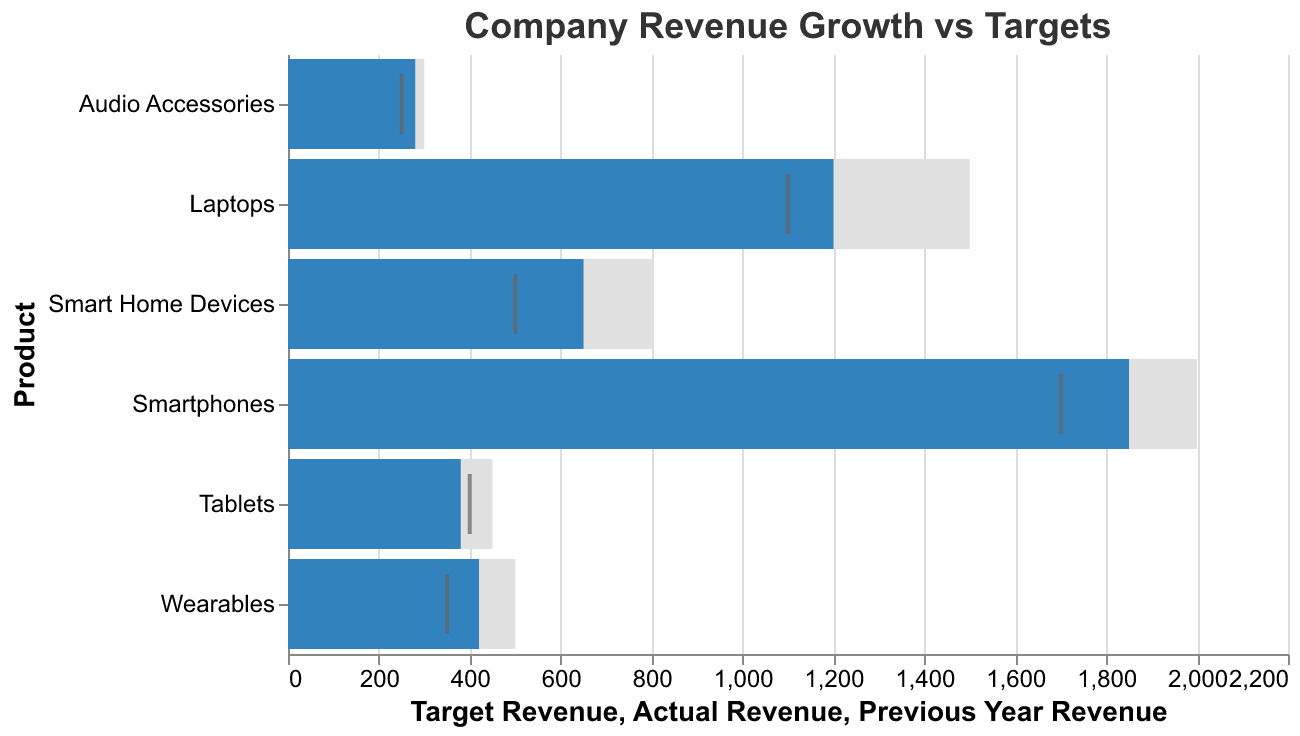How many product lines are displayed in the figure? Count each product listed on the y-axis, which includes Smartphones, Laptops, Smart Home Devices, Wearables, Tablets, and Audio Accessories, totaling six product lines.
Answer: Six What is the target revenue for Smart Home Devices? The target revenue for each product is visually represented by the length of the grey bar. For Smart Home Devices, it reaches up to 800 on the x-axis.
Answer: 800 Which product line achieved the highest actual revenue? Compare the lengths of the blue bars for each product. The Smartphones product line has the longest blue bar, indicating the highest actual revenue.
Answer: Smartphones Did the actual revenue for Wearables exceed their revenue from the previous year? Compare the position of the blue bar (actual revenue) and the black tick mark (previous year revenue) for Wearables. The blue bar reaches 420, which is higher than the tick mark at 350.
Answer: Yes What is the total target revenue for all product lines combined? Add the target revenues for all products: 2000 (Smartphones) + 1500 (Laptops) + 800 (Smart Home Devices) + 500 (Wearables) + 450 (Tablets) + 300 (Audio Accessories).
Answer: 5550 Which product line shows the highest growth in actual revenue compared to the previous year? Subtract the previous year revenue from the actual revenue for each product. The one with the highest positive difference is the product line with the highest growth. Smartphones: 1850-1700, Laptops: 1200-1100, Smart Home Devices: 650-500, Wearables: 420-350, Tablets: 380-400, Audio Accessories: 280-250.
Answer: Smartphones Which product line is closest to achieving its target revenue? Compare the difference between actual revenue and target revenue for each product. The smallest difference indicates the closest to achieving the target. Smartphones: 2000-1850, Laptops: 1500-1200, Smart Home Devices: 800-650, Wearables: 500-420, Tablets: 450-380, Audio Accessories: 300-280.
Answer: Audio Accessories Are there any product lines where the actual revenue is less than the previous year’s revenue? Compare the blue bar (actual revenue) with the black tick mark (previous year revenue) for each product. Tablets have an actual revenue (380) below the previous year revenue (400).
Answer: Tablets What is the average target revenue across all product lines? Calculate the average by dividing the total target revenue by the number of product lines. Total target revenue is 5550, and there are 6 product lines.
Answer: 925 Which product line has the lowest actual revenue? Compare the lengths of the blue bars for each product. The shortest blue bar represents the Audio Accessories product line.
Answer: Audio Accessories 